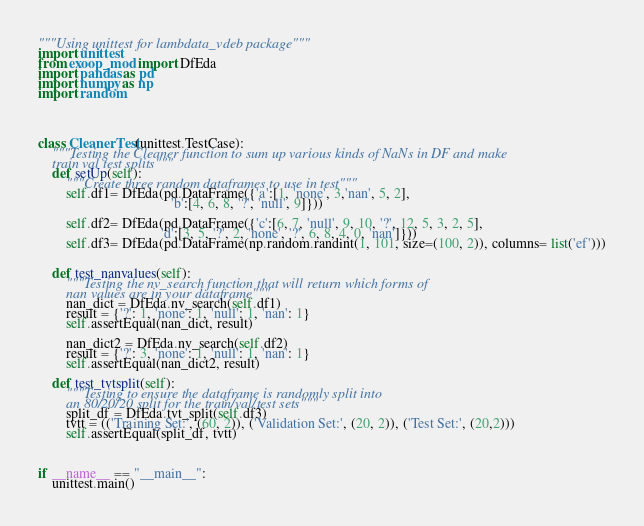<code> <loc_0><loc_0><loc_500><loc_500><_Python_>"""Using unittest for lambdata_vdeb package"""
import unittest
from exoop_mod import DfEda
import pandas as pd
import numpy as np
import random




class CleanerTest(unittest.TestCase):
    """Testing the Cleaner function to sum up various kinds of NaNs in DF and make 
    train val test splits"""
    def setUp(self):
        """Create three random dataframes to use in test"""
        self.df1= DfEda(pd.DataFrame({'a':[1, 'none', 3,'nan', 5, 2],
                                      'b':[4, 6, 8, '?', 'null', 9]}))
                              
        self.df2= DfEda(pd.DataFrame({'c':[6, 7, 'null', 9, 10, '?', 12, 5, 3, 2, 5],
                                   'd':[3, 5, '?', 2, 'none', '?', 6, 8, 4, 0, 'nan']}))
        self.df3= DfEda(pd.DataFrame(np.random.randint(1, 101, size=(100, 2)), columns= list('ef')))


    def test_nanvalues(self):
        """Testing the nv_search function that will return which forms of 
        nan values are in your dataframe"""
        nan_dict = DfEda.nv_search(self.df1)
        result = {'?': 1, 'none': 1, 'null': 1, 'nan': 1}
        self.assertEqual(nan_dict, result)

        nan_dict2 = DfEda.nv_search(self.df2)
        result = {'?': 3, 'none': 1, 'null': 1, 'nan': 1}
        self.assertEqual(nan_dict2, result)

    def test_tvtsplit(self):
        """Testing to ensure the dataframe is randomly split into 
        an 80/20/20 split for the train/val/test sets"""
        split_df = DfEda.tvt_split(self.df3)
        tvtt = (('Training Set:', (60, 2)), ('Validation Set:', (20, 2)), ('Test Set:', (20,2)))
        self.assertEqual(split_df, tvtt)



if __name__ == "__main__":
    unittest.main()</code> 